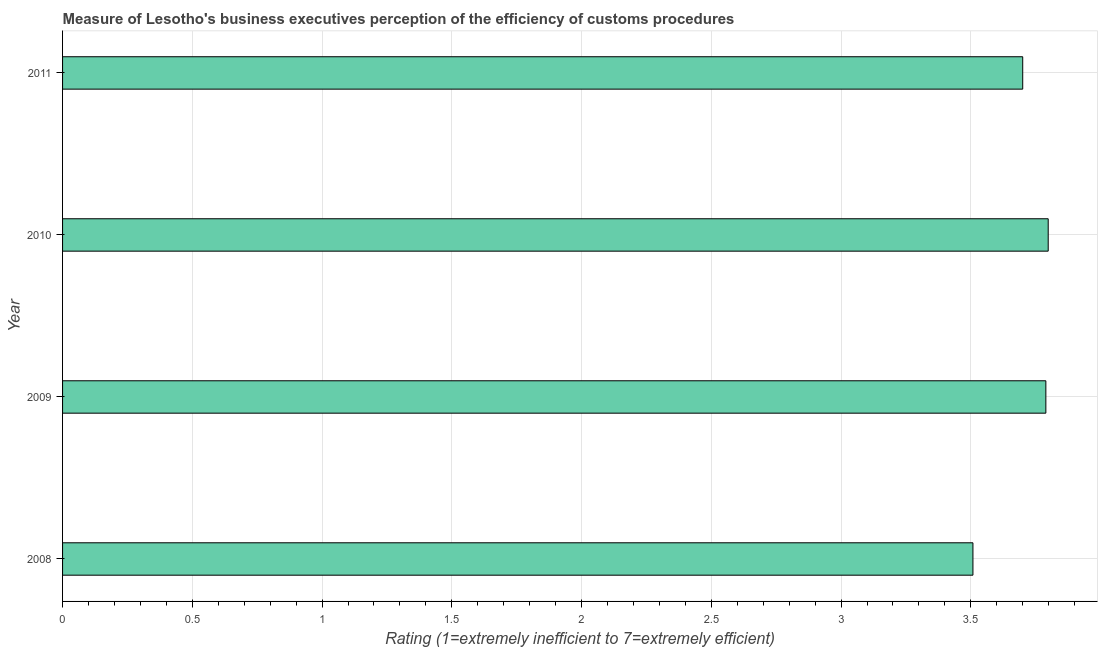What is the title of the graph?
Provide a succinct answer. Measure of Lesotho's business executives perception of the efficiency of customs procedures. What is the label or title of the X-axis?
Keep it short and to the point. Rating (1=extremely inefficient to 7=extremely efficient). What is the label or title of the Y-axis?
Offer a very short reply. Year. What is the rating measuring burden of customs procedure in 2010?
Make the answer very short. 3.8. Across all years, what is the maximum rating measuring burden of customs procedure?
Your answer should be compact. 3.8. Across all years, what is the minimum rating measuring burden of customs procedure?
Make the answer very short. 3.51. In which year was the rating measuring burden of customs procedure maximum?
Ensure brevity in your answer.  2010. What is the sum of the rating measuring burden of customs procedure?
Give a very brief answer. 14.8. What is the difference between the rating measuring burden of customs procedure in 2009 and 2011?
Give a very brief answer. 0.09. What is the average rating measuring burden of customs procedure per year?
Provide a short and direct response. 3.7. What is the median rating measuring burden of customs procedure?
Your answer should be very brief. 3.74. Do a majority of the years between 2011 and 2010 (inclusive) have rating measuring burden of customs procedure greater than 1.8 ?
Ensure brevity in your answer.  No. Is the difference between the rating measuring burden of customs procedure in 2008 and 2010 greater than the difference between any two years?
Keep it short and to the point. Yes. What is the difference between the highest and the second highest rating measuring burden of customs procedure?
Your answer should be compact. 0.01. Is the sum of the rating measuring burden of customs procedure in 2010 and 2011 greater than the maximum rating measuring burden of customs procedure across all years?
Make the answer very short. Yes. What is the difference between the highest and the lowest rating measuring burden of customs procedure?
Offer a terse response. 0.29. In how many years, is the rating measuring burden of customs procedure greater than the average rating measuring burden of customs procedure taken over all years?
Offer a terse response. 3. How many years are there in the graph?
Make the answer very short. 4. What is the Rating (1=extremely inefficient to 7=extremely efficient) of 2008?
Keep it short and to the point. 3.51. What is the Rating (1=extremely inefficient to 7=extremely efficient) in 2009?
Ensure brevity in your answer.  3.79. What is the Rating (1=extremely inefficient to 7=extremely efficient) in 2010?
Ensure brevity in your answer.  3.8. What is the difference between the Rating (1=extremely inefficient to 7=extremely efficient) in 2008 and 2009?
Your response must be concise. -0.28. What is the difference between the Rating (1=extremely inefficient to 7=extremely efficient) in 2008 and 2010?
Offer a terse response. -0.29. What is the difference between the Rating (1=extremely inefficient to 7=extremely efficient) in 2008 and 2011?
Offer a terse response. -0.19. What is the difference between the Rating (1=extremely inefficient to 7=extremely efficient) in 2009 and 2010?
Provide a succinct answer. -0.01. What is the difference between the Rating (1=extremely inefficient to 7=extremely efficient) in 2009 and 2011?
Offer a very short reply. 0.09. What is the difference between the Rating (1=extremely inefficient to 7=extremely efficient) in 2010 and 2011?
Your answer should be very brief. 0.1. What is the ratio of the Rating (1=extremely inefficient to 7=extremely efficient) in 2008 to that in 2009?
Keep it short and to the point. 0.93. What is the ratio of the Rating (1=extremely inefficient to 7=extremely efficient) in 2008 to that in 2010?
Keep it short and to the point. 0.92. What is the ratio of the Rating (1=extremely inefficient to 7=extremely efficient) in 2008 to that in 2011?
Provide a succinct answer. 0.95. What is the ratio of the Rating (1=extremely inefficient to 7=extremely efficient) in 2009 to that in 2010?
Provide a short and direct response. 1. What is the ratio of the Rating (1=extremely inefficient to 7=extremely efficient) in 2009 to that in 2011?
Your answer should be very brief. 1.02. 